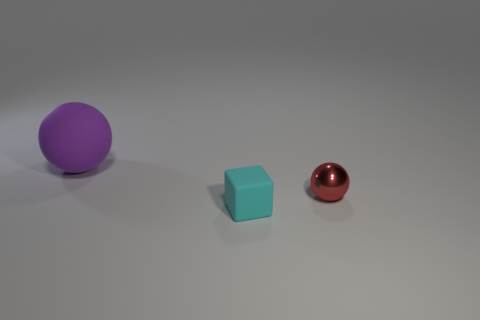Add 2 gray objects. How many objects exist? 5 Subtract all cubes. How many objects are left? 2 Add 3 small red metal spheres. How many small red metal spheres are left? 4 Add 2 large purple objects. How many large purple objects exist? 3 Subtract 0 red blocks. How many objects are left? 3 Subtract all big purple matte cylinders. Subtract all small cubes. How many objects are left? 2 